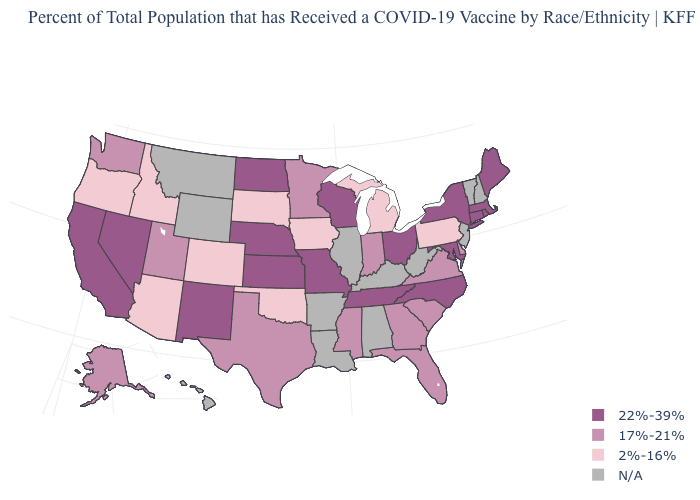What is the highest value in states that border Oregon?
Quick response, please. 22%-39%. How many symbols are there in the legend?
Keep it brief. 4. Name the states that have a value in the range 22%-39%?
Write a very short answer. California, Connecticut, Kansas, Maine, Maryland, Massachusetts, Missouri, Nebraska, Nevada, New Mexico, New York, North Carolina, North Dakota, Ohio, Rhode Island, Tennessee, Wisconsin. What is the value of Oregon?
Concise answer only. 2%-16%. Which states have the highest value in the USA?
Answer briefly. California, Connecticut, Kansas, Maine, Maryland, Massachusetts, Missouri, Nebraska, Nevada, New Mexico, New York, North Carolina, North Dakota, Ohio, Rhode Island, Tennessee, Wisconsin. Does North Dakota have the highest value in the MidWest?
Write a very short answer. Yes. Name the states that have a value in the range 2%-16%?
Concise answer only. Arizona, Colorado, Idaho, Iowa, Michigan, Oklahoma, Oregon, Pennsylvania, South Dakota. What is the highest value in states that border Minnesota?
Short answer required. 22%-39%. What is the value of New Mexico?
Concise answer only. 22%-39%. Name the states that have a value in the range 17%-21%?
Concise answer only. Alaska, Delaware, Florida, Georgia, Indiana, Minnesota, Mississippi, South Carolina, Texas, Utah, Virginia, Washington. What is the highest value in the USA?
Answer briefly. 22%-39%. Among the states that border Texas , does Oklahoma have the lowest value?
Write a very short answer. Yes. Does Delaware have the highest value in the USA?
Keep it brief. No. 